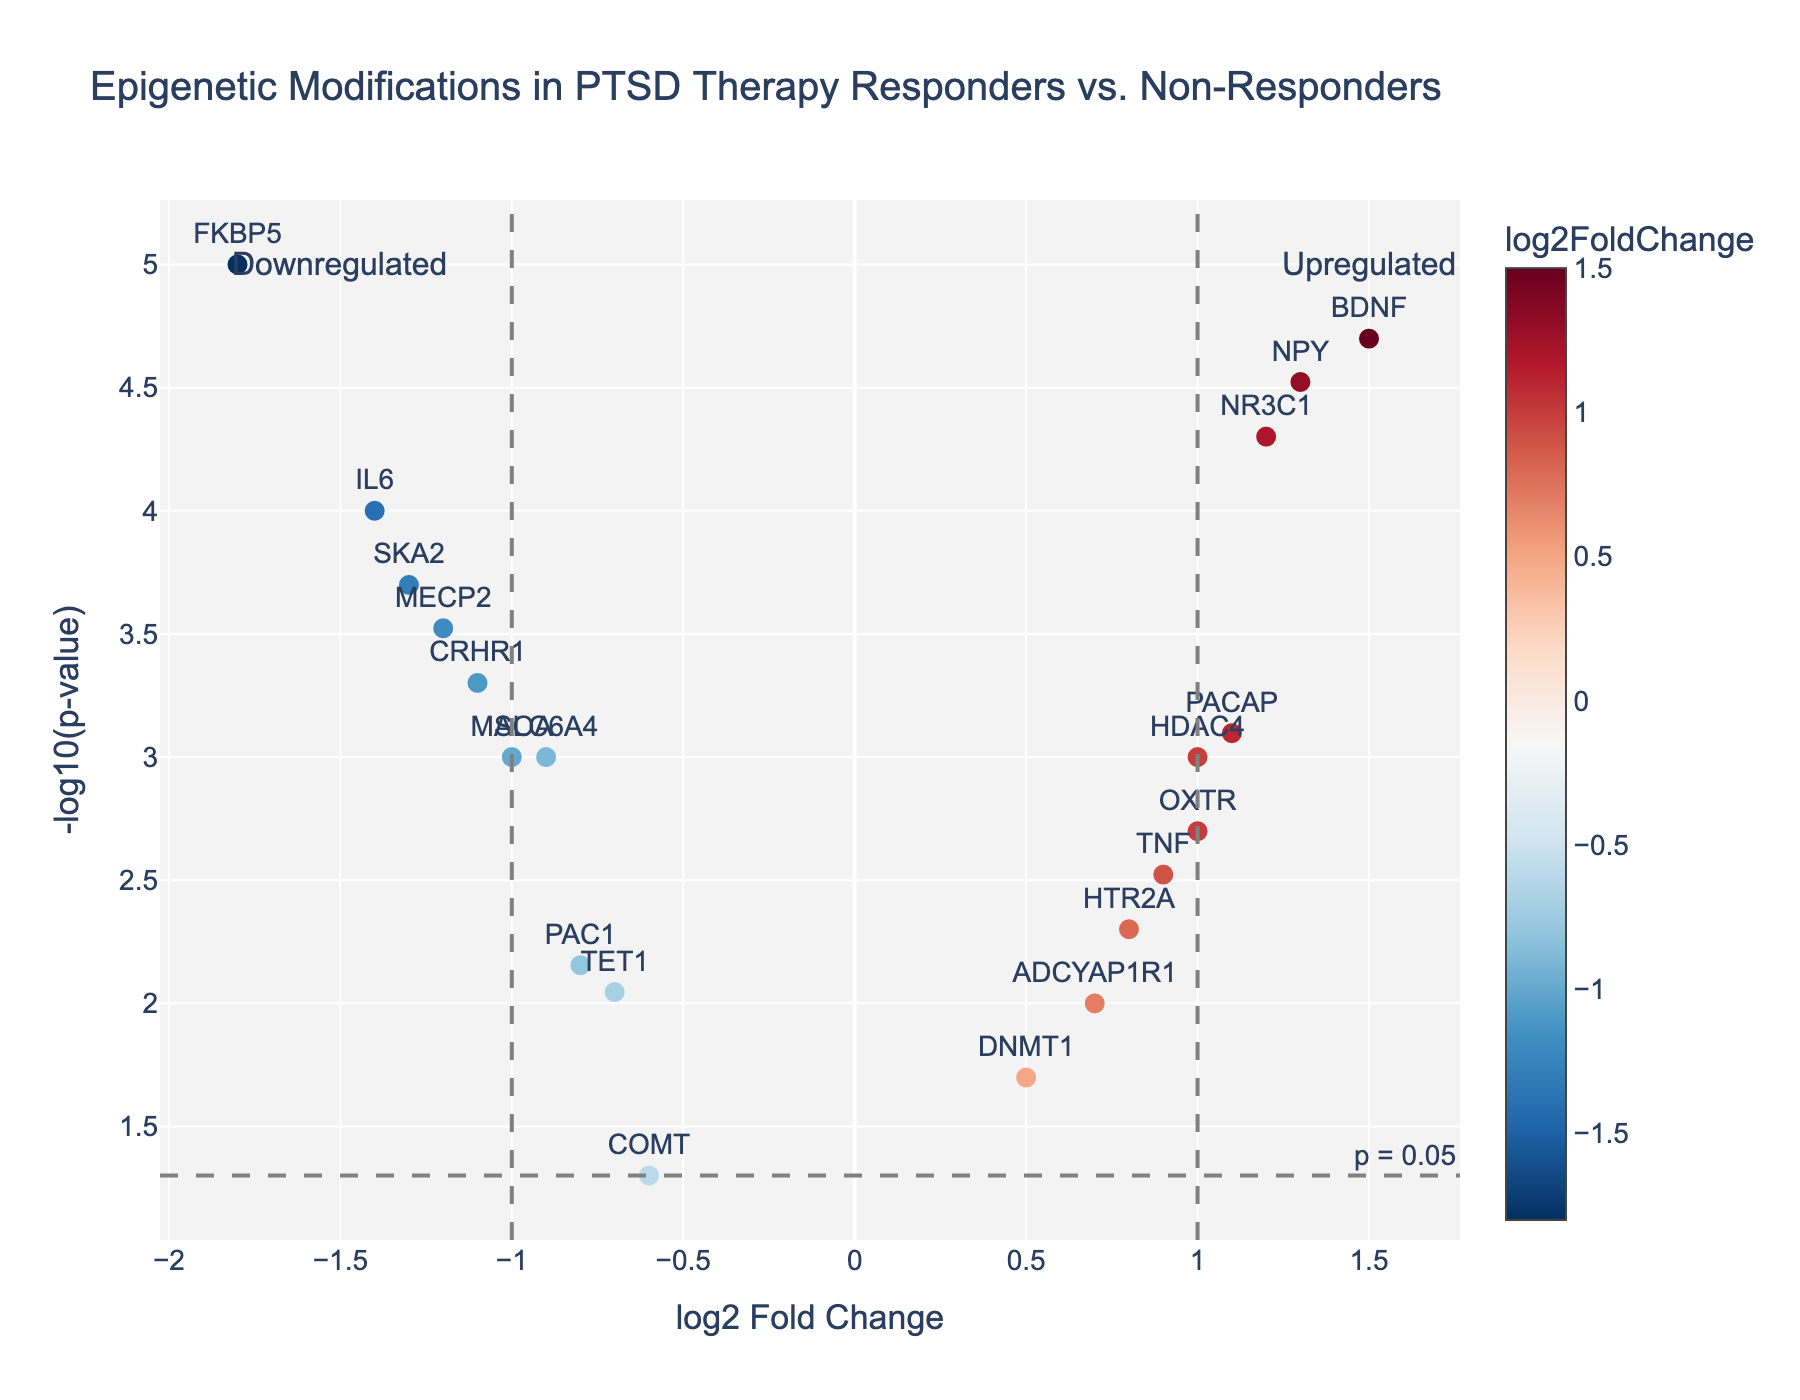What is the title of the figure? The title of the figure is located at the top and directly provides a concise description of the plot's theme.
Answer: Epigenetic Modifications in PTSD Therapy Responders vs. Non-Responders What do the X and Y axes represent? The X and Y axes titles indicate the variables represented: X-axis for "log2 Fold Change" and Y-axis for "-log10(p-value)."
Answer: X-axis: log2 Fold Change, Y-axis: -log10(p-value) Which gene shows the highest statistical significance (i.e., lowest p-value)? The highest statistical significance corresponds to the highest value on the Y-axis (-log10(p-value)). Observe the gene label at this highest point.
Answer: FKBP5 Which gene has the highest log2 Fold Change? The gene with the highest log2 Fold Change is seen at the far right on the X-axis. Examine its label.
Answer: BDNF How many genes are downregulated with a log2 Fold Change less than -1 and statistically significant (p < 0.05)? Identify genes with log2 Fold Change < -1 and Y values above the threshold line indicating -log10(0.05). Count these points.
Answer: 4 Which gene shows the largest negative log2 Fold Change and what is its p-value? The largest negative log2 Fold Change is identified on the extreme left of the X-axis. The p-value can be deduced from the corresponding Y value using its inverse (-log10).
Answer: FKBP5, 0.00001 How does the expression level of CRHR1 compare to that of PACAP in terms of log2 Fold Change and p-value? Compare the X (log2 Fold Change) and Y (-log10(p-value)) positions of CRHR1 and PACAP. CRHR1 has negative log2 Fold Change with different p-values than PACAP.
Answer: CRHR1: -1.1, 0.0005; PACAP: 1.1, 0.0008 Are there any genes with log2 Fold Change near zero but still statistically significant? If so, name them. Find data points close to zero on the X-axis yet above the Y-axis threshold line for -log10(0.05), indicating significance.
Answer: DNMT1 How many genes are upregulated with positive log2 Fold Change and a p-value less than 0.001? Examine genes with positive log2 Fold Change on the right side of the X-axis and Y values above the line representing -log10(0.001) for significance.
Answer: 5 What is the similarity between OXTR and HTR2A in terms of their log2 Fold Change and p-value? Compare OXTR and HTR2A points: log2 Fold Change values close to 1 and gently differing p-values slightly above -log10(0.005).
Answer: Both have similar positive log2 Fold Change around 1 with slightly different p-values 